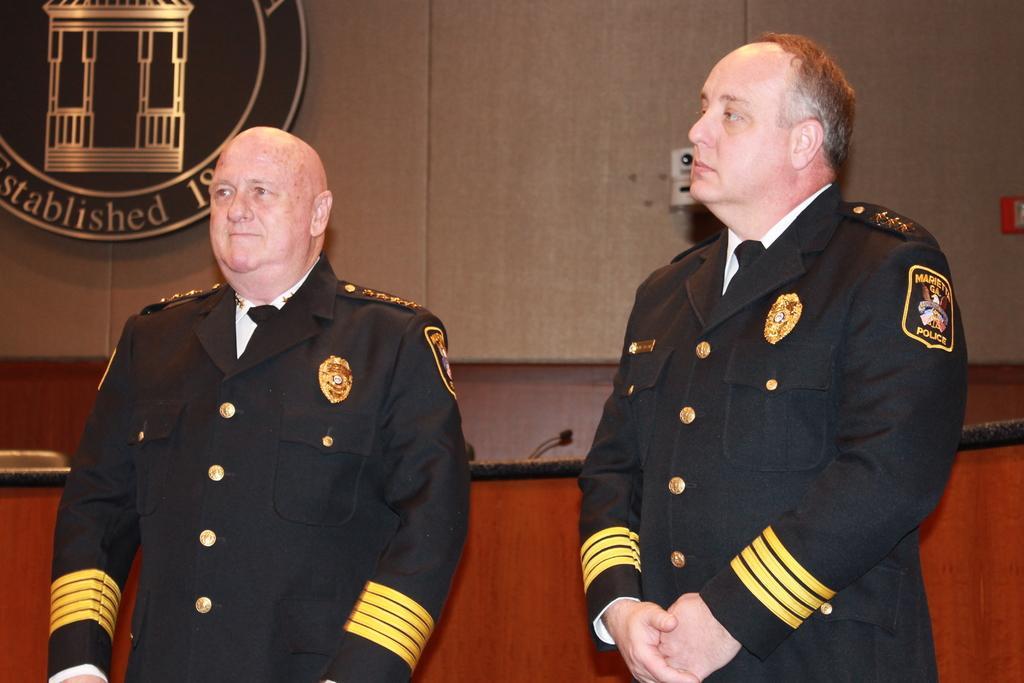Describe this image in one or two sentences. In the image I can see two men standing wearing clothes, I can see the microphone, wall and the logo. 